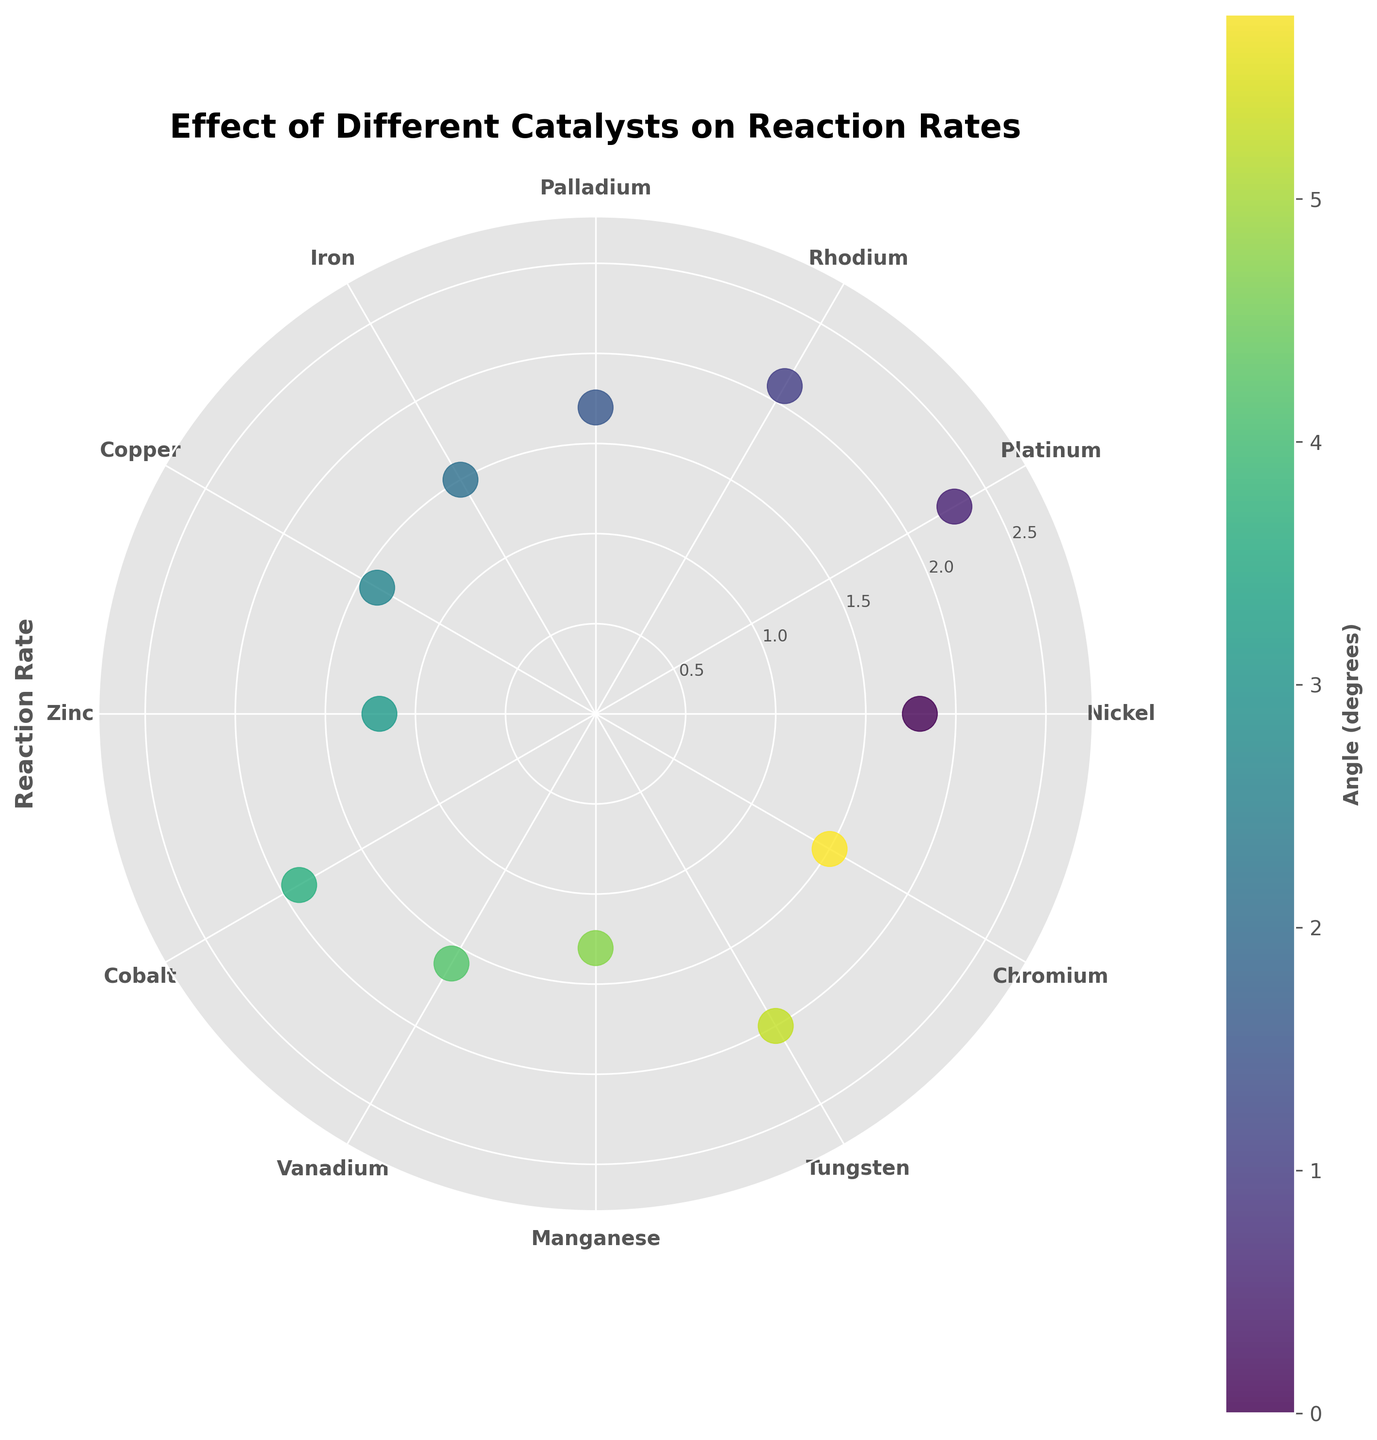What is the title of the figure? The title of the figure is written at the top and usually in a larger, bold font. It states the main subject of the chart.
Answer: Effect of Different Catalysts on Reaction Rates How many catalysts are represented in the figure? Count the number of distinct catalyst names on the angular tick labels.
Answer: 12 Which catalyst has the highest reaction rate? Look for the point that is the furthest from the center of the chart, which represents the highest value on the radial axis.
Answer: Platinum What is the reaction rate of the catalyst Iron? Locate the angular tick labeled 'Iron' and find the corresponding point's distance from the center to read off its reaction rate value.
Answer: 1.5 Compare the reaction rates of Nickel and Zinc. Which one is higher and by how much? Find the radial distances of 'Nickel' and 'Zinc'. Subtract the reaction rate of Zinc from Nickel.
Answer: Nickel is higher by 0.6 What is the average reaction rate of all catalysts? Sum all the reaction rates and divide by the number of catalysts. (1.8 + 2.3 + 2.1 + 1.7 + 1.5 + 1.4 + 1.2 + 1.9 + 1.6 + 1.3 + 2.0 + 1.5) / 12 = 20.3 / 12
Answer: 1.69 Which catalyst has the lowest reaction rate and what is its value? Look for the point closest to the center of the chart, representing the lowest value on the radial axis, and read the corresponding catalyst name and rate.
Answer: Zinc, 1.2 What is the sum of the reaction rates for Cobalt and Vanadium? Find the reaction rates for Cobalt and Vanadium and add them together. (1.9 + 1.6)
Answer: 3.5 How are the data points colored in the figure? Identify any noticeable color pattern among the data points, for instance, whether it follows a specific color gradient or map, which can usually be referenced by the colorbar legend.
Answer: Based on the angle in degrees Considering the radial positions, which two catalysts have reaction rates closest to each other and what is the difference? Compare all the reaction rates and identify the two that have the smallest absolute difference. The smallest difference is between Cobalt (1.9) and Nickel (1.8). (1.9 - 1.8)
Answer: Cobalt and Nickel, 0.1 